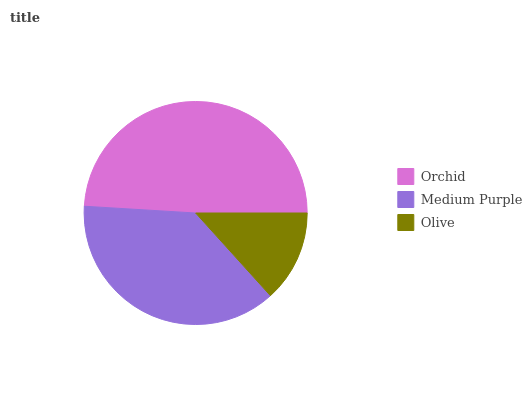Is Olive the minimum?
Answer yes or no. Yes. Is Orchid the maximum?
Answer yes or no. Yes. Is Medium Purple the minimum?
Answer yes or no. No. Is Medium Purple the maximum?
Answer yes or no. No. Is Orchid greater than Medium Purple?
Answer yes or no. Yes. Is Medium Purple less than Orchid?
Answer yes or no. Yes. Is Medium Purple greater than Orchid?
Answer yes or no. No. Is Orchid less than Medium Purple?
Answer yes or no. No. Is Medium Purple the high median?
Answer yes or no. Yes. Is Medium Purple the low median?
Answer yes or no. Yes. Is Orchid the high median?
Answer yes or no. No. Is Orchid the low median?
Answer yes or no. No. 